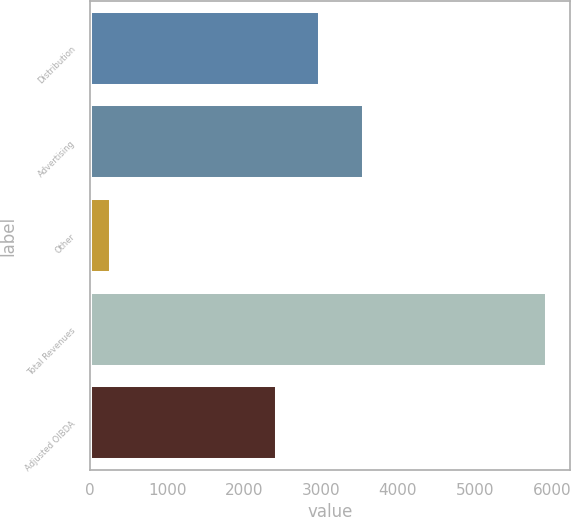<chart> <loc_0><loc_0><loc_500><loc_500><bar_chart><fcel>Distribution<fcel>Advertising<fcel>Other<fcel>Total Revenues<fcel>Adjusted OIBDA<nl><fcel>2989.4<fcel>3555.8<fcel>271<fcel>5935<fcel>2423<nl></chart> 